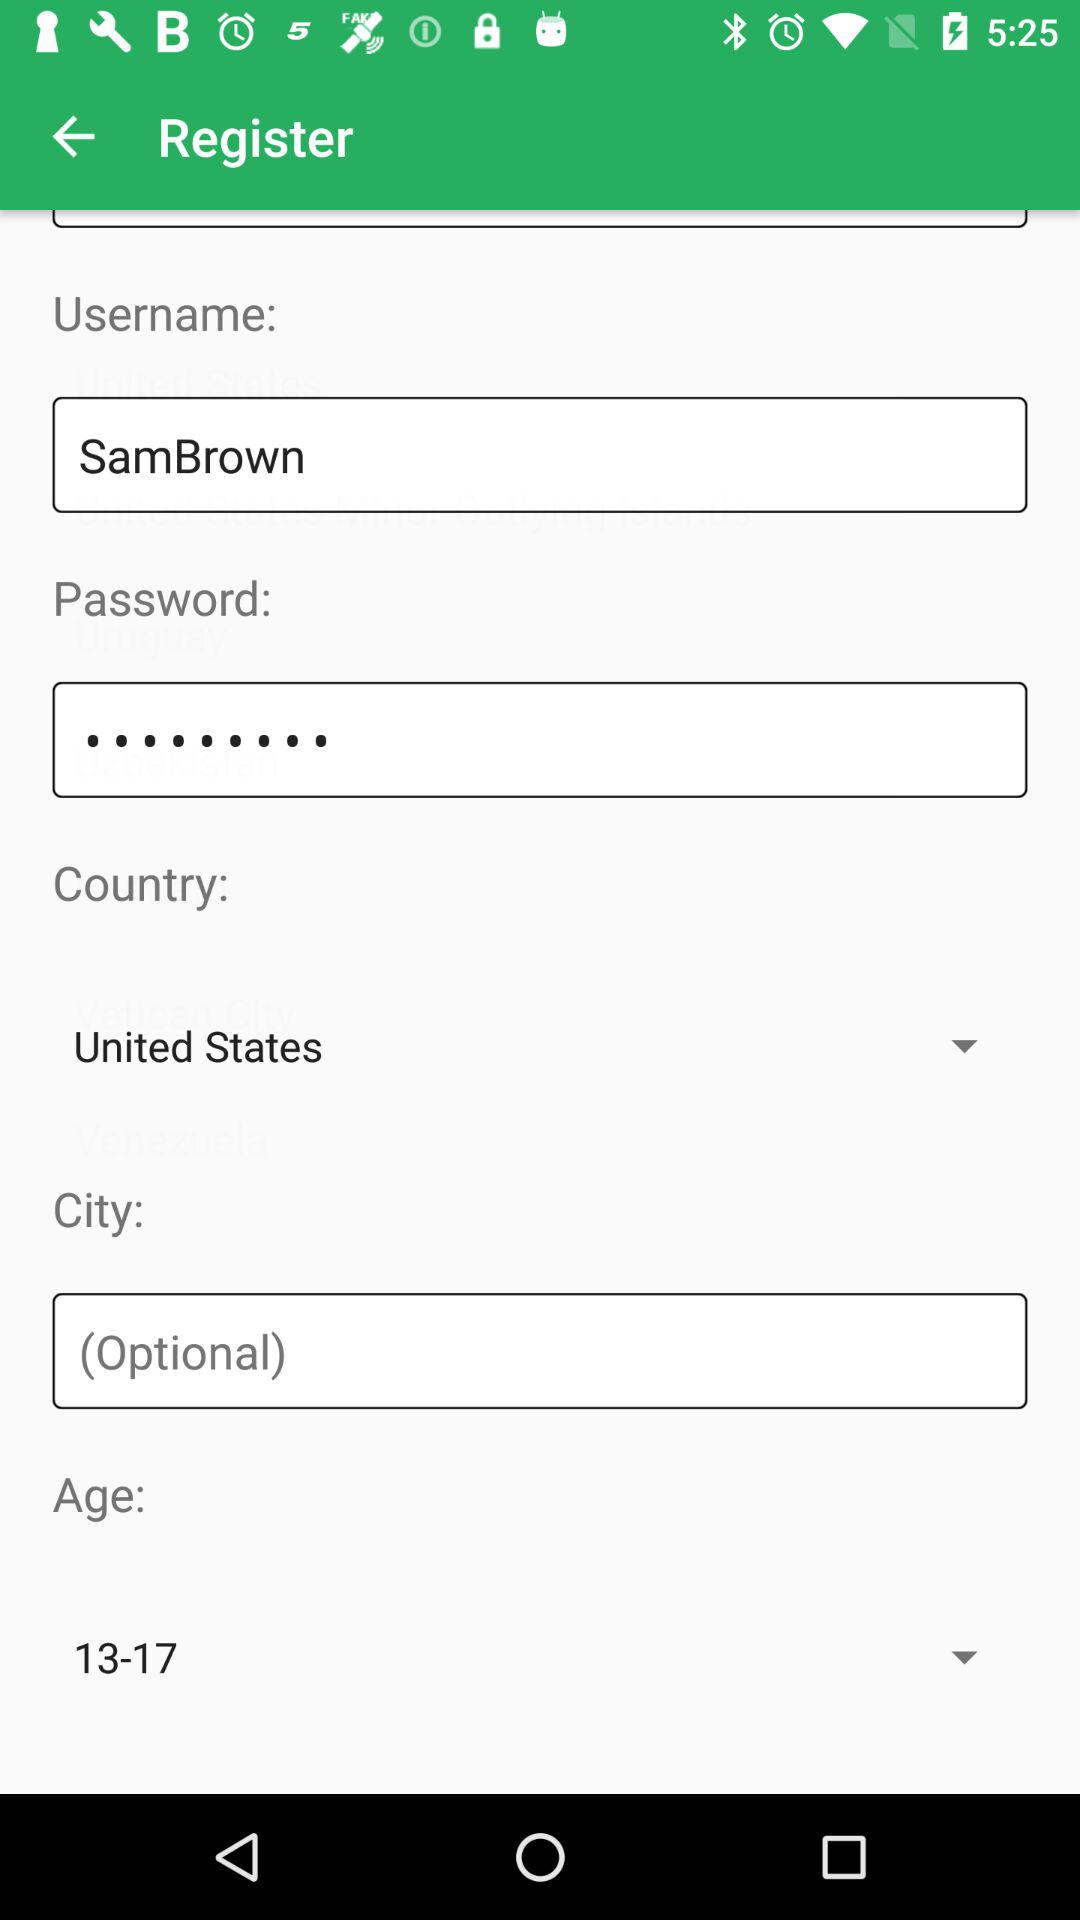What is the username? The username is "SamBrown". 